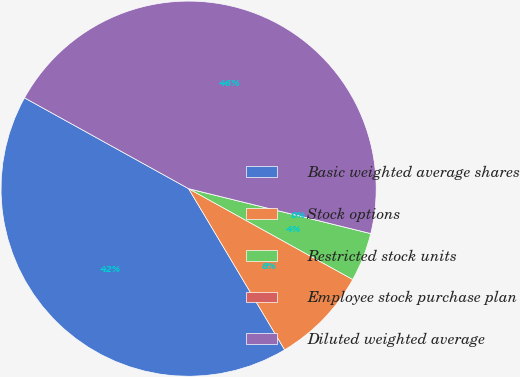Convert chart to OTSL. <chart><loc_0><loc_0><loc_500><loc_500><pie_chart><fcel>Basic weighted average shares<fcel>Stock options<fcel>Restricted stock units<fcel>Employee stock purchase plan<fcel>Diluted weighted average<nl><fcel>41.6%<fcel>8.4%<fcel>4.2%<fcel>0.0%<fcel>45.8%<nl></chart> 